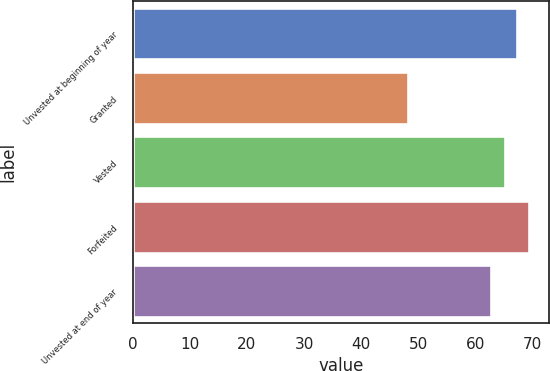Convert chart to OTSL. <chart><loc_0><loc_0><loc_500><loc_500><bar_chart><fcel>Unvested at beginning of year<fcel>Granted<fcel>Vested<fcel>Forfeited<fcel>Unvested at end of year<nl><fcel>67.26<fcel>48.14<fcel>65.15<fcel>69.37<fcel>62.75<nl></chart> 